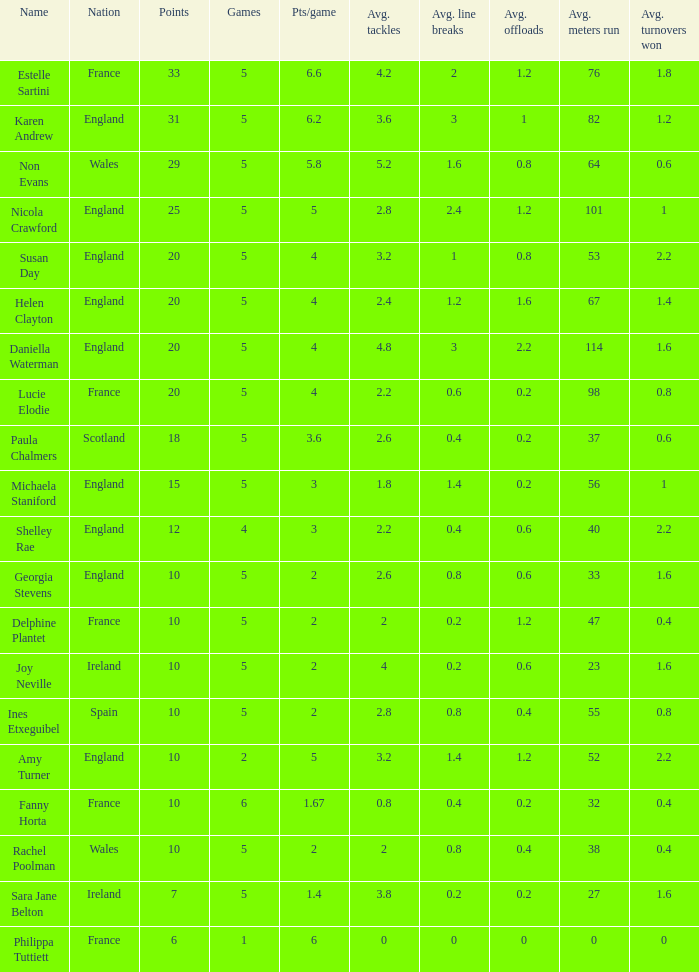Can you tell me the lowest Pts/game that has the Games larger than 6? None. 